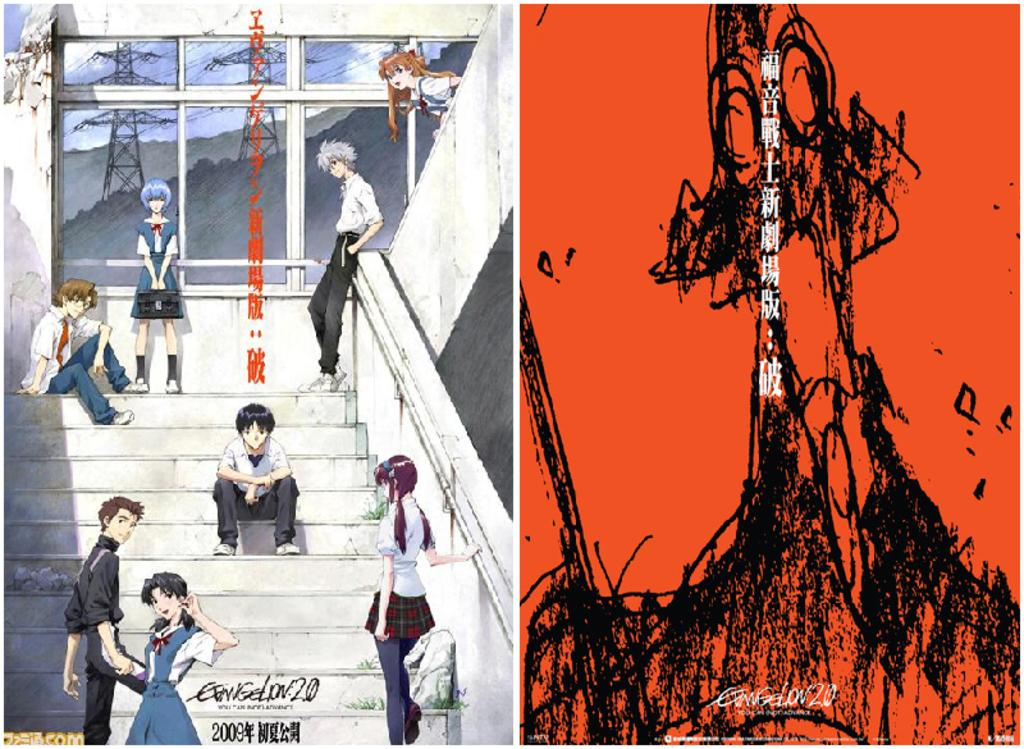<image>
Render a clear and concise summary of the photo. Two Anime pictures next to each other have Chinese writing down the center and are dated 2009. 